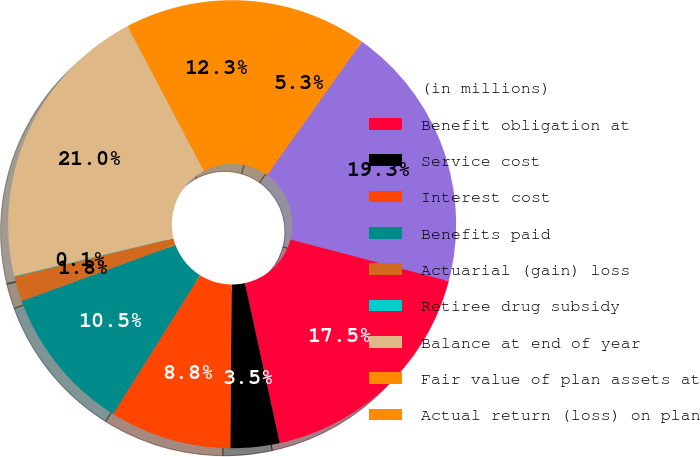Convert chart. <chart><loc_0><loc_0><loc_500><loc_500><pie_chart><fcel>(in millions)<fcel>Benefit obligation at<fcel>Service cost<fcel>Interest cost<fcel>Benefits paid<fcel>Actuarial (gain) loss<fcel>Retiree drug subsidy<fcel>Balance at end of year<fcel>Fair value of plan assets at<fcel>Actual return (loss) on plan<nl><fcel>19.25%<fcel>17.5%<fcel>3.54%<fcel>8.78%<fcel>10.52%<fcel>1.8%<fcel>0.05%<fcel>20.99%<fcel>12.27%<fcel>5.29%<nl></chart> 